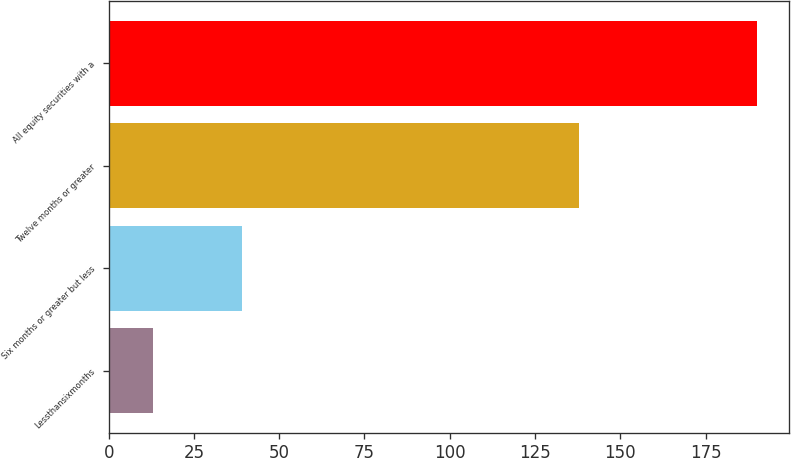<chart> <loc_0><loc_0><loc_500><loc_500><bar_chart><fcel>Lessthansixmonths<fcel>Six months or greater but less<fcel>Twelve months or greater<fcel>All equity securities with a<nl><fcel>13<fcel>39<fcel>138<fcel>190<nl></chart> 